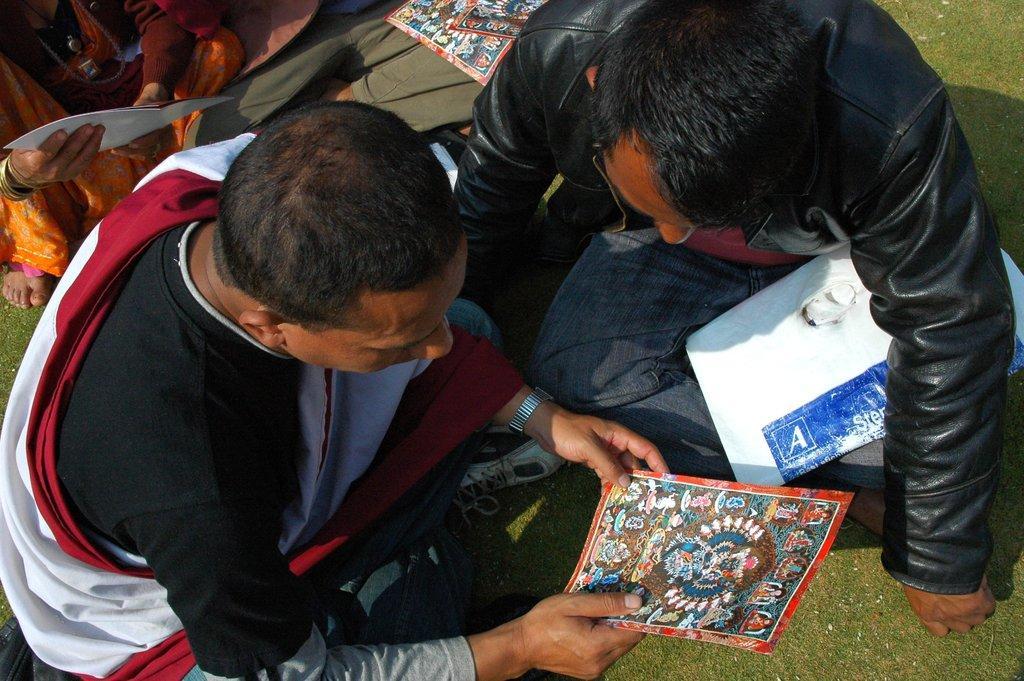Describe this image in one or two sentences. In this image we can see this person is holding a poster in his hands and sitting on the ground. Also, we can see a few more people sitting on the ground. 